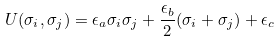<formula> <loc_0><loc_0><loc_500><loc_500>U ( \sigma _ { i } , \sigma _ { j } ) = \epsilon _ { a } \sigma _ { i } \sigma _ { j } + \frac { \epsilon _ { b } } { 2 } ( \sigma _ { i } + \sigma _ { j } ) + \epsilon _ { c }</formula> 